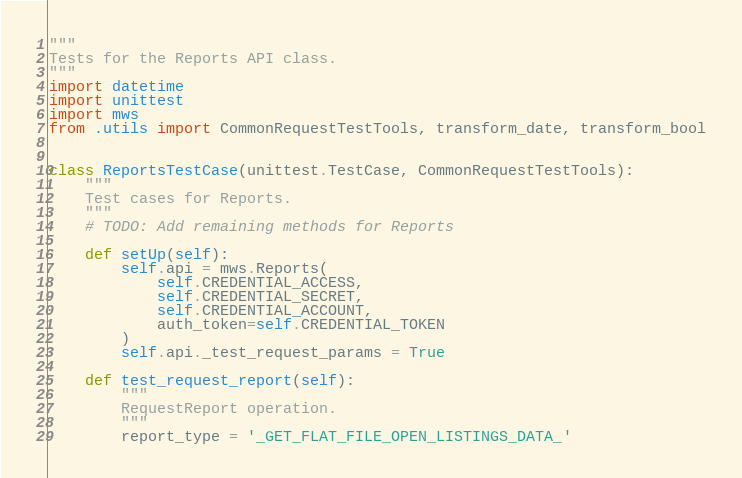<code> <loc_0><loc_0><loc_500><loc_500><_Python_>"""
Tests for the Reports API class.
"""
import datetime
import unittest
import mws
from .utils import CommonRequestTestTools, transform_date, transform_bool


class ReportsTestCase(unittest.TestCase, CommonRequestTestTools):
    """
    Test cases for Reports.
    """
    # TODO: Add remaining methods for Reports

    def setUp(self):
        self.api = mws.Reports(
            self.CREDENTIAL_ACCESS,
            self.CREDENTIAL_SECRET,
            self.CREDENTIAL_ACCOUNT,
            auth_token=self.CREDENTIAL_TOKEN
        )
        self.api._test_request_params = True

    def test_request_report(self):
        """
        RequestReport operation.
        """
        report_type = '_GET_FLAT_FILE_OPEN_LISTINGS_DATA_'</code> 